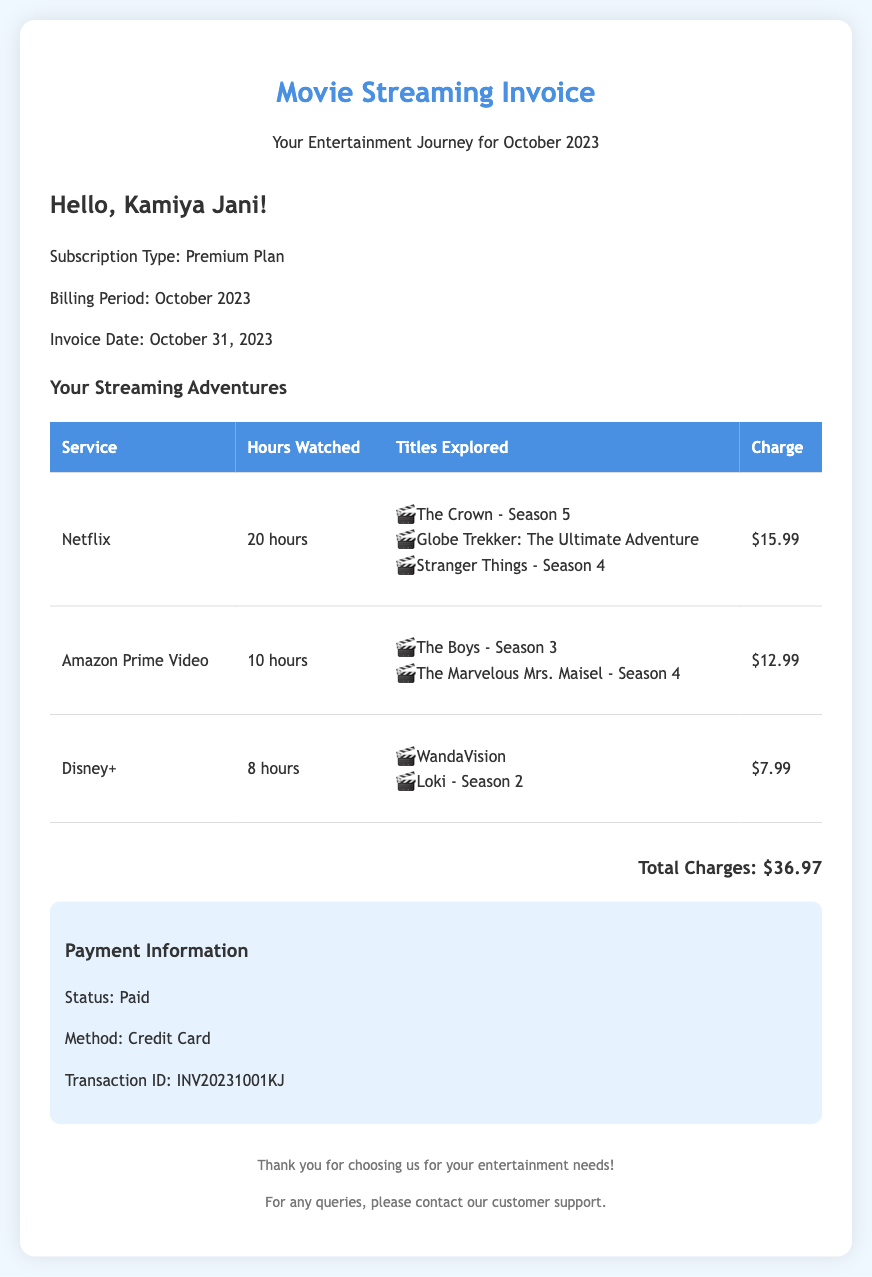What is the subscription type? The subscription type is mentioned in the document as Premium Plan.
Answer: Premium Plan What is the total charge for the month? The total charge is highlighted in the invoice as $36.97.
Answer: $36.97 How many hours were watched on Netflix? The document specifies that 20 hours were watched on Netflix.
Answer: 20 hours What are the titles explored on Amazon Prime Video? The titles explored on Amazon Prime Video are listed as The Boys - Season 3 and The Marvelous Mrs. Maisel - Season 4.
Answer: The Boys - Season 3, The Marvelous Mrs. Maisel - Season 4 What is the payment status? The payment status is stated clearly in the document as Paid.
Answer: Paid How many hours were watched in total across all services? By adding the hours watched on each service (20 + 10 + 8), we see the total is 38 hours.
Answer: 38 hours What method was used for payment? The invoice notes the payment method used as Credit Card.
Answer: Credit Card When is the billing period for this invoice? The billing period is specified in the document as October 2023.
Answer: October 2023 What is the Transaction ID? The Transaction ID is provided in the payment information section as INV20231001KJ.
Answer: INV20231001KJ 